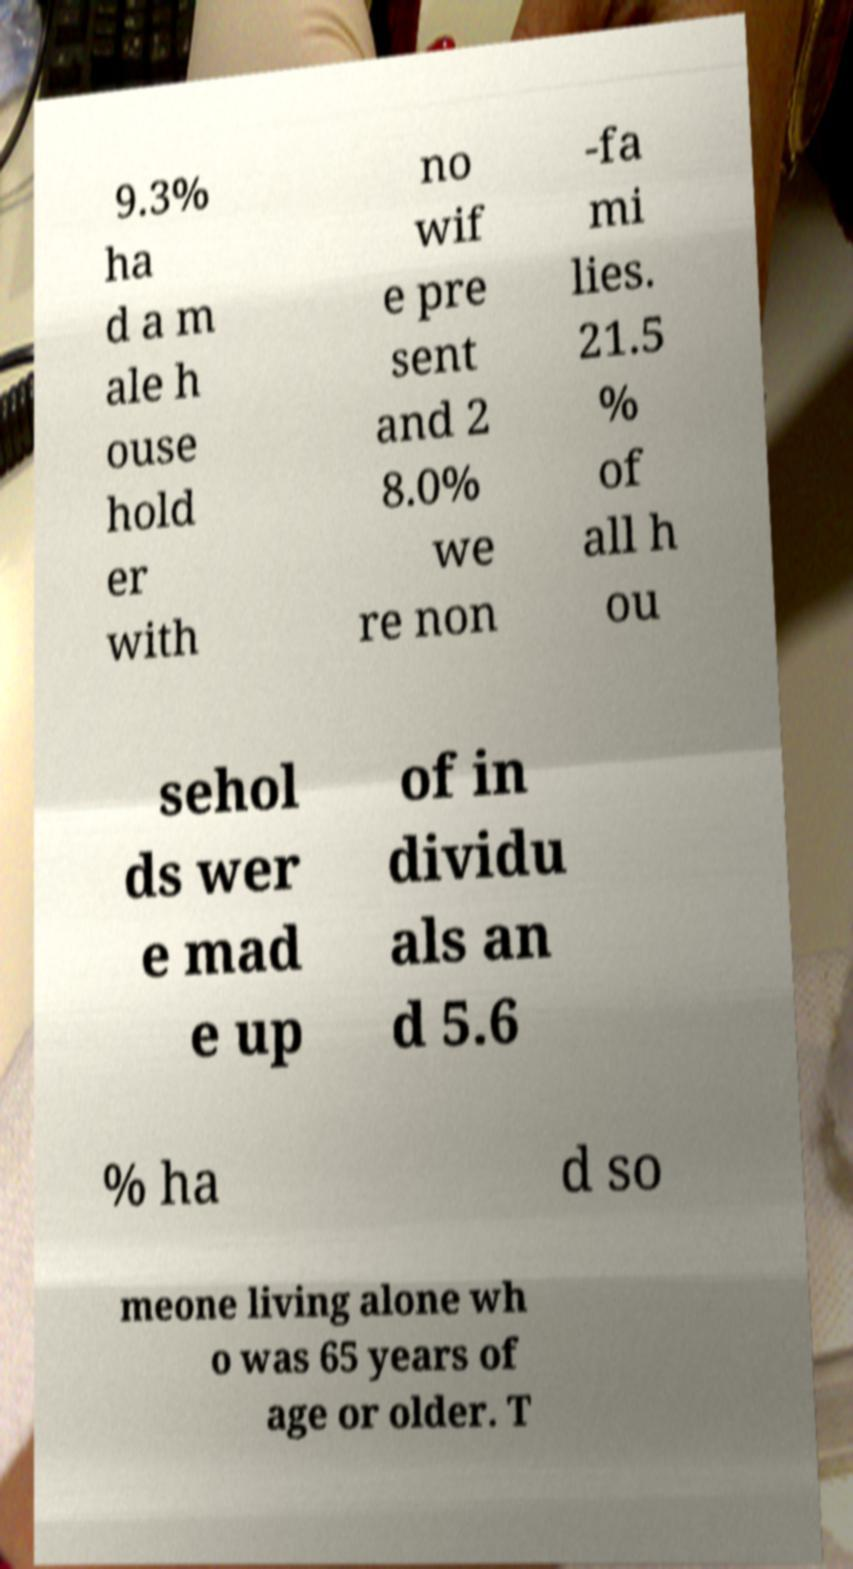Could you extract and type out the text from this image? 9.3% ha d a m ale h ouse hold er with no wif e pre sent and 2 8.0% we re non -fa mi lies. 21.5 % of all h ou sehol ds wer e mad e up of in dividu als an d 5.6 % ha d so meone living alone wh o was 65 years of age or older. T 